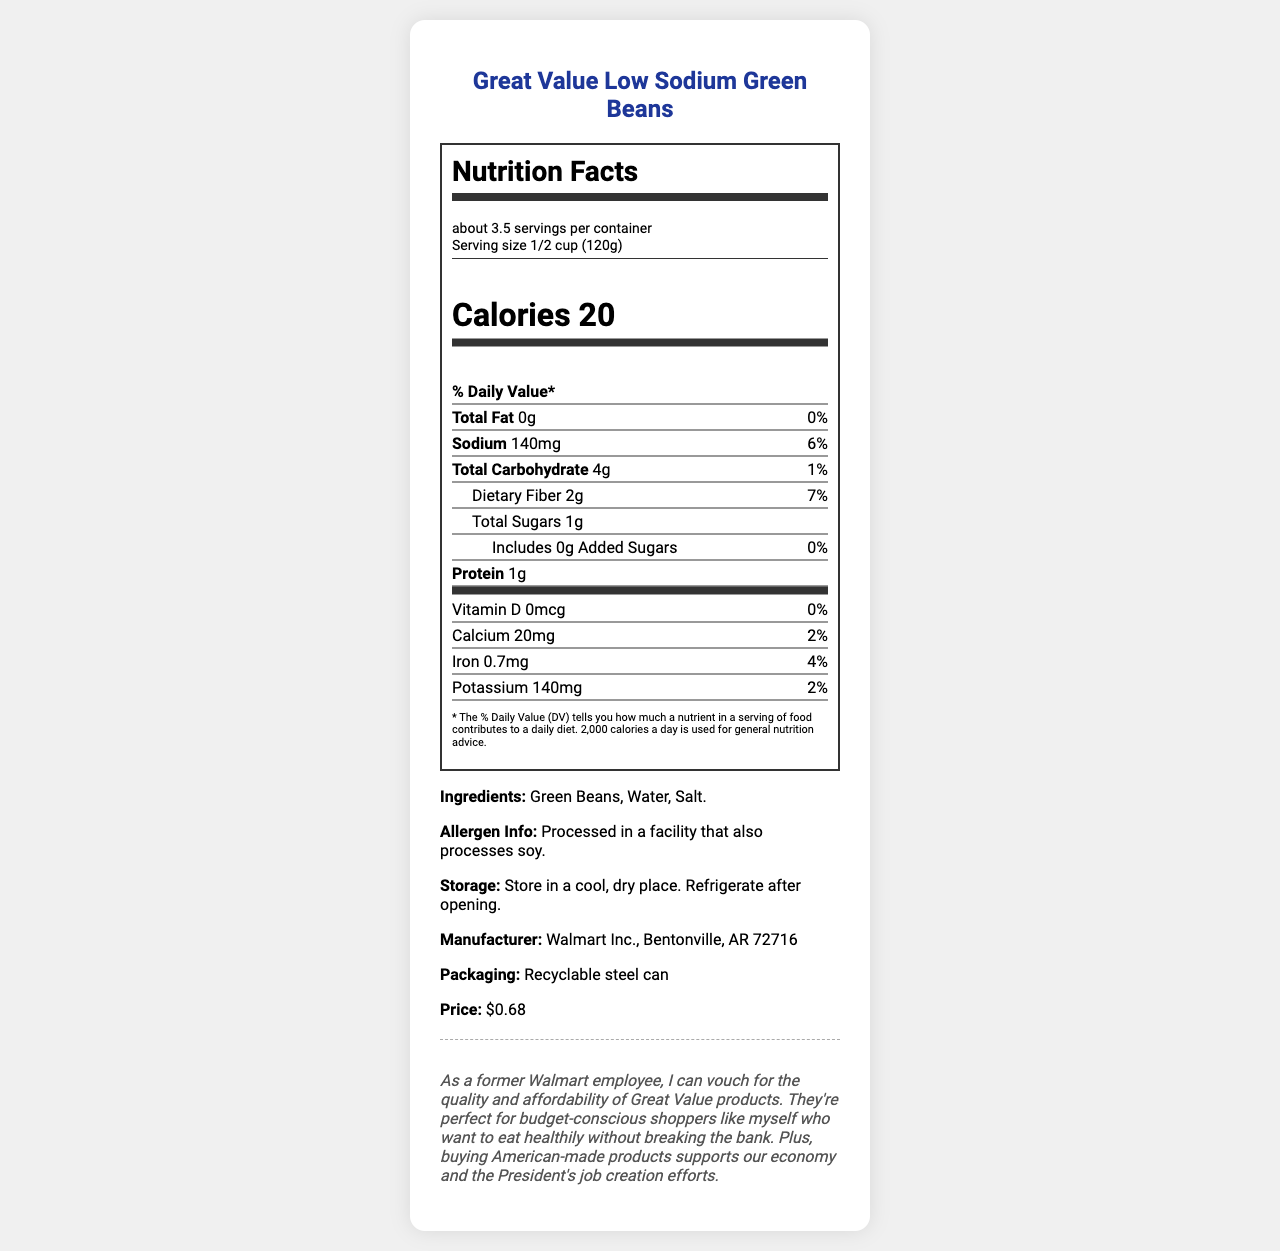what is the serving size? The serving size is specified at the top of the nutrition label under "Serving size."
Answer: 1/2 cup (120g) how many calories are in one serving? The calories per serving are given in the section under the "Calories" header.
Answer: 20 what is the amount of sodium per serving? The amount of sodium per serving is listed as 140mg in the nutrition label section.
Answer: 140mg what percentage of the daily value of calcium does one serving provide? The daily value percentage for calcium is listed as 2% in the vitamins section of the nutrition label.
Answer: 2% how much dietary fiber is in one serving? The dietary fiber content per serving is mentioned below the total carbohydrate entry, indicating 2g per serving.
Answer: 2g what are the main ingredients listed for this product? The ingredients are specified at the bottom of the document under "Ingredients."
Answer: Green Beans, Water, Salt what is the price of this product? A. $0.58 B. $0.68 C. $0.78 The price of the product is given as $0.68 in the bottom section of the document.
Answer: B what company manufactures this product? I. Procter & Gamble II. Walmart Inc. III. Unilever The manufacturer is listed as Walmart Inc. in the information section at the bottom of the document.
Answer: II is this product made from organic ingredients? There is no mention of the product being organic in the document.
Answer: No what should you do after opening the can? The storage instructions indicate to refrigerate the product after opening.
Answer: Refrigerate describe the packaging type of this product. The packaging type is mentioned as a recyclable steel can in the information section.
Answer: Recyclable steel can can this product be stored in a warm place? The storage instructions specify to store in a cool, dry place, implying it should not be stored in a warm place.
Answer: No how much protein does each serving contain? The protein content for each serving is specified as 1g in the nutrition label section.
Answer: 1g what is the personal note about the product? The personal note is provided at the bottom of the document, commenting on the quality, affordability, and support for the economy.
Answer: As a former Walmart employee, I can vouch for the quality and affordability of Great Value products. They're perfect for budget-conscious shoppers like myself who want to eat healthily without breaking the bank. Plus, buying American-made products supports our economy and the President's job creation efforts. what is the image format used in the document generation code? The image format used is not specified in the document and relates to the coding details, which are not visible in the document.
Answer: Cannot be determined 